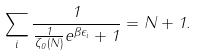Convert formula to latex. <formula><loc_0><loc_0><loc_500><loc_500>\sum _ { i } \frac { 1 } { \frac { 1 } { \zeta _ { 0 } ( N ) } e ^ { \beta \epsilon _ { i } } + 1 } = N + 1 .</formula> 